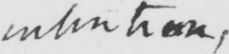Please transcribe the handwritten text in this image. intention , 